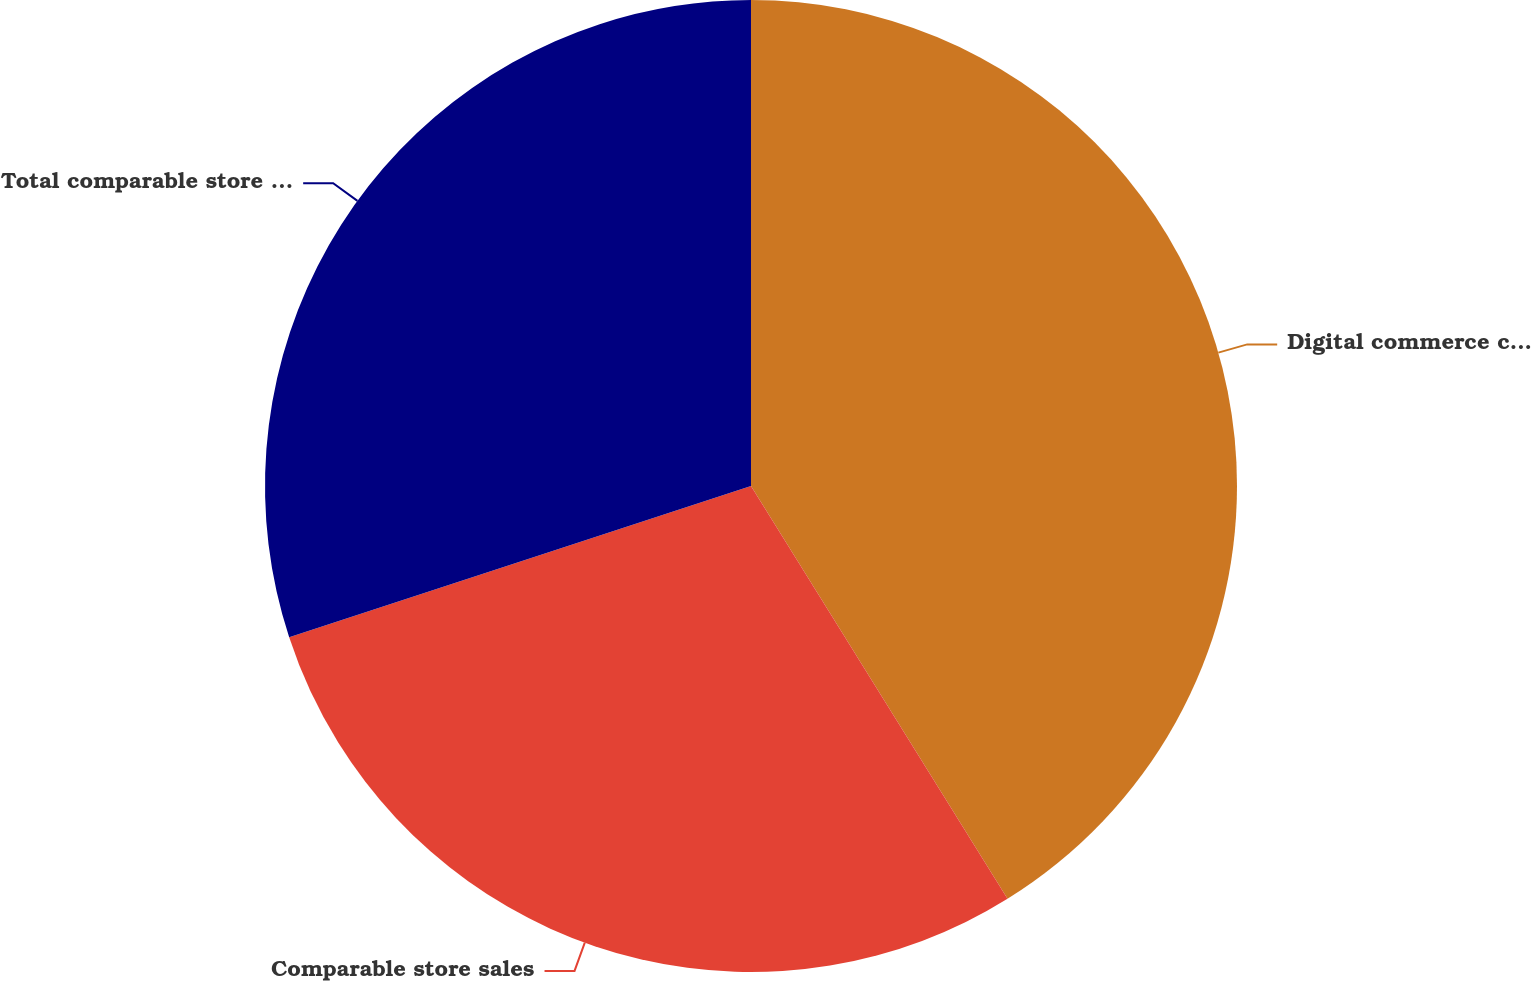Convert chart to OTSL. <chart><loc_0><loc_0><loc_500><loc_500><pie_chart><fcel>Digital commerce comparable<fcel>Comparable store sales<fcel>Total comparable store sales<nl><fcel>41.15%<fcel>28.81%<fcel>30.04%<nl></chart> 